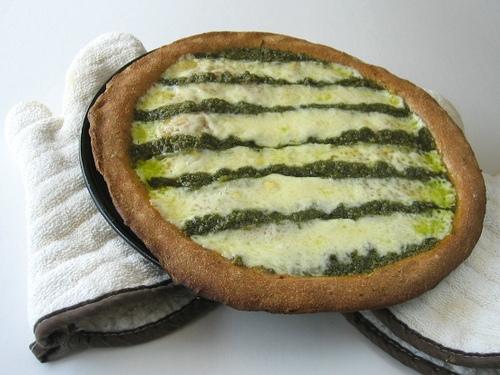What kind of pizza is this?
Quick response, please. Spinach. How many oven mitts are there?
Quick response, please. 2. What is the purpose of the mitts underneath the pizza?
Quick response, please. Protect from heat. 